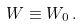<formula> <loc_0><loc_0><loc_500><loc_500>W \equiv W _ { 0 } \, .</formula> 